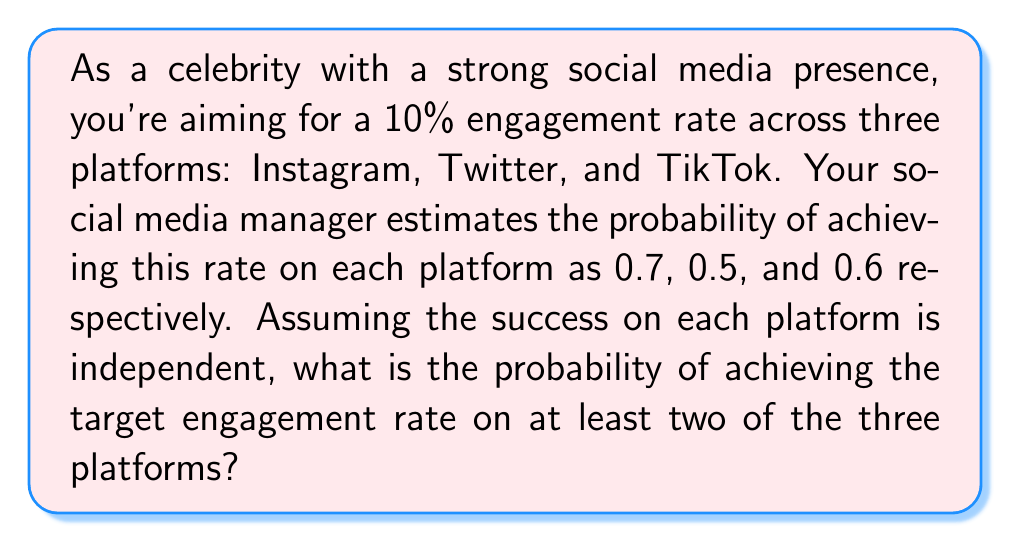Give your solution to this math problem. Let's approach this step-by-step using the concept of complementary events and the addition rule of probability.

1) First, let's define our events:
   I: Success on Instagram (P(I) = 0.7)
   T: Success on Twitter (P(T) = 0.5)
   K: Success on TikTok (P(K) = 0.6)

2) We want the probability of success on at least two platforms. It's easier to calculate the complement of this event: the probability of success on fewer than two platforms (i.e., on one or zero platforms).

3) Let's calculate the probability of failure on each platform:
   P(not I) = 1 - 0.7 = 0.3
   P(not T) = 1 - 0.5 = 0.5
   P(not K) = 1 - 0.6 = 0.4

4) Now, we can calculate the probability of failing on all platforms:
   P(fail all) = 0.3 * 0.5 * 0.4 = 0.06

5) Next, let's calculate the probability of succeeding on exactly one platform:
   P(only I) = 0.7 * 0.5 * 0.4 = 0.14
   P(only T) = 0.3 * 0.5 * 0.4 = 0.06
   P(only K) = 0.3 * 0.5 * 0.6 = 0.09

6) The probability of succeeding on fewer than two platforms is the sum of failing on all and succeeding on exactly one:
   P(fewer than two) = 0.06 + 0.14 + 0.06 + 0.09 = 0.35

7) Therefore, the probability of succeeding on at least two platforms is:
   P(at least two) = 1 - P(fewer than two) = 1 - 0.35 = 0.65

Thus, the probability of achieving the target engagement rate on at least two of the three platforms is 0.65 or 65%.
Answer: 0.65 